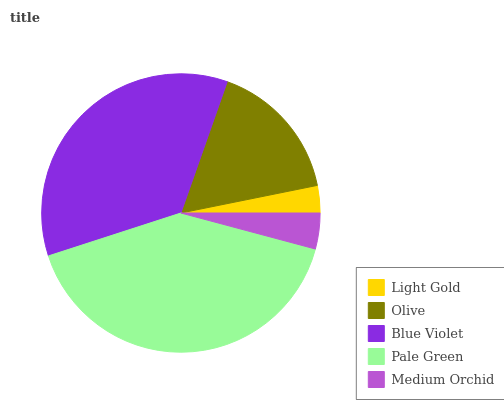Is Light Gold the minimum?
Answer yes or no. Yes. Is Pale Green the maximum?
Answer yes or no. Yes. Is Olive the minimum?
Answer yes or no. No. Is Olive the maximum?
Answer yes or no. No. Is Olive greater than Light Gold?
Answer yes or no. Yes. Is Light Gold less than Olive?
Answer yes or no. Yes. Is Light Gold greater than Olive?
Answer yes or no. No. Is Olive less than Light Gold?
Answer yes or no. No. Is Olive the high median?
Answer yes or no. Yes. Is Olive the low median?
Answer yes or no. Yes. Is Pale Green the high median?
Answer yes or no. No. Is Blue Violet the low median?
Answer yes or no. No. 